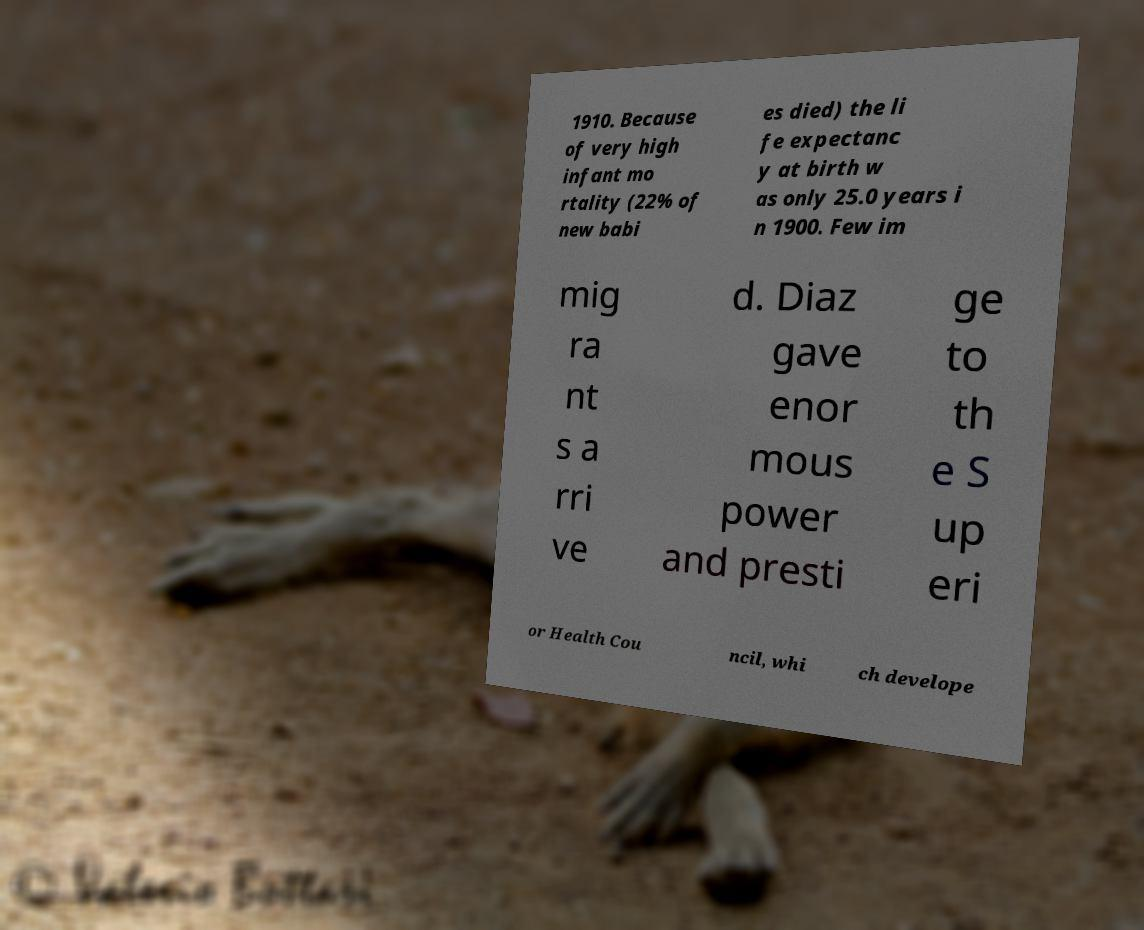Please read and relay the text visible in this image. What does it say? 1910. Because of very high infant mo rtality (22% of new babi es died) the li fe expectanc y at birth w as only 25.0 years i n 1900. Few im mig ra nt s a rri ve d. Diaz gave enor mous power and presti ge to th e S up eri or Health Cou ncil, whi ch develope 